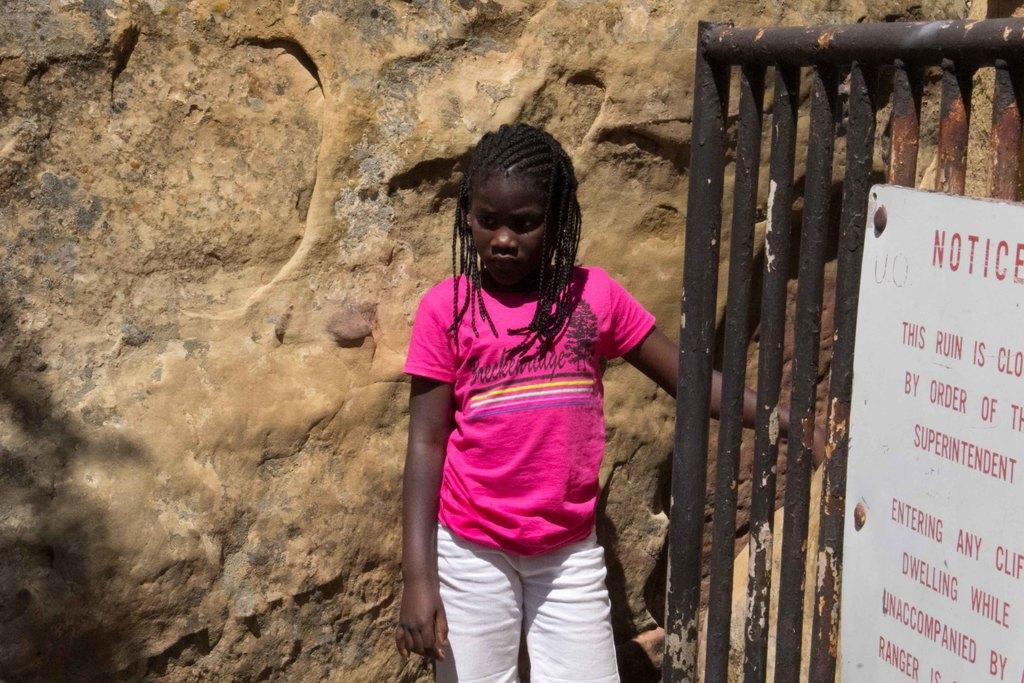Who is present in the image? There is a girl standing in the image. What is behind the girl in the image? There is a wall behind the girl. What object can be seen in the image besides the girl and the wall? There is a board and rods in the image. What type of berry is the girl holding in the image? There is no berry present in the image; the girl is not holding anything. 